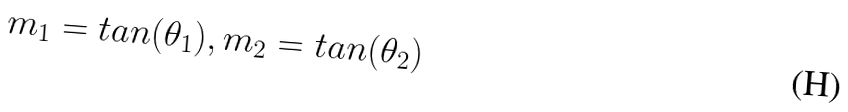Convert formula to latex. <formula><loc_0><loc_0><loc_500><loc_500>m _ { 1 } = t a n ( \theta _ { 1 } ) , m _ { 2 } = t a n ( \theta _ { 2 } )</formula> 